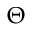<formula> <loc_0><loc_0><loc_500><loc_500>\Theta</formula> 